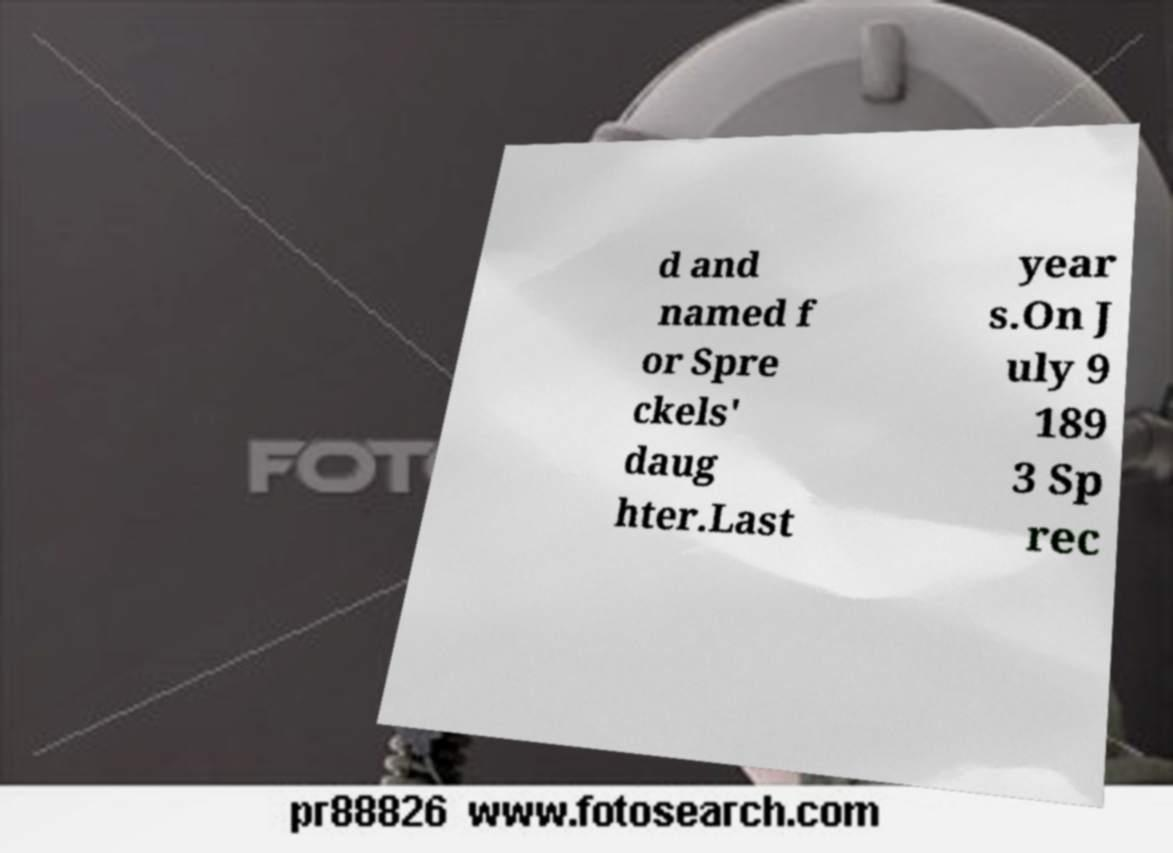Can you accurately transcribe the text from the provided image for me? d and named f or Spre ckels' daug hter.Last year s.On J uly 9 189 3 Sp rec 